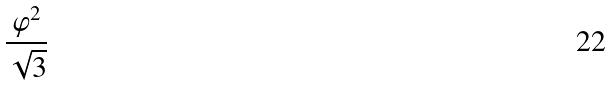<formula> <loc_0><loc_0><loc_500><loc_500>\frac { \varphi ^ { 2 } } { \sqrt { 3 } }</formula> 